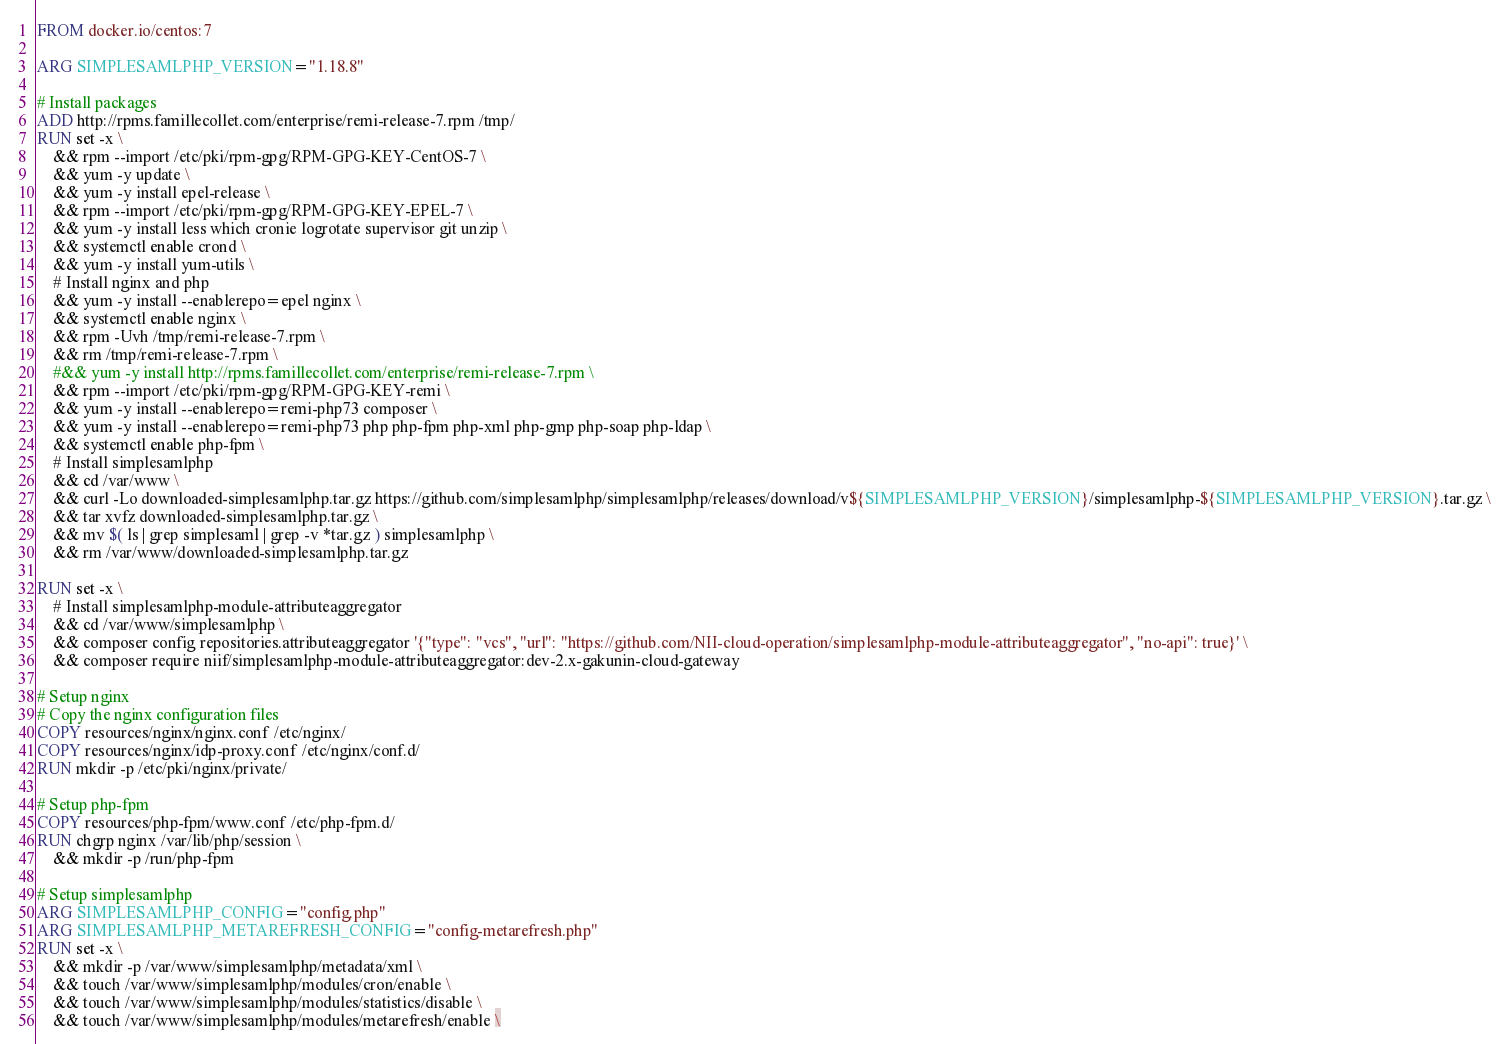Convert code to text. <code><loc_0><loc_0><loc_500><loc_500><_Dockerfile_>FROM docker.io/centos:7

ARG SIMPLESAMLPHP_VERSION="1.18.8"

# Install packages
ADD http://rpms.famillecollet.com/enterprise/remi-release-7.rpm /tmp/
RUN set -x \
    && rpm --import /etc/pki/rpm-gpg/RPM-GPG-KEY-CentOS-7 \
    && yum -y update \
    && yum -y install epel-release \
    && rpm --import /etc/pki/rpm-gpg/RPM-GPG-KEY-EPEL-7 \
    && yum -y install less which cronie logrotate supervisor git unzip \
    && systemctl enable crond \
    && yum -y install yum-utils \
    # Install nginx and php
    && yum -y install --enablerepo=epel nginx \
    && systemctl enable nginx \
    && rpm -Uvh /tmp/remi-release-7.rpm \
    && rm /tmp/remi-release-7.rpm \
    #&& yum -y install http://rpms.famillecollet.com/enterprise/remi-release-7.rpm \
    && rpm --import /etc/pki/rpm-gpg/RPM-GPG-KEY-remi \
    && yum -y install --enablerepo=remi-php73 composer \
    && yum -y install --enablerepo=remi-php73 php php-fpm php-xml php-gmp php-soap php-ldap \
    && systemctl enable php-fpm \
    # Install simplesamlphp
    && cd /var/www \
    && curl -Lo downloaded-simplesamlphp.tar.gz https://github.com/simplesamlphp/simplesamlphp/releases/download/v${SIMPLESAMLPHP_VERSION}/simplesamlphp-${SIMPLESAMLPHP_VERSION}.tar.gz \
    && tar xvfz downloaded-simplesamlphp.tar.gz \
    && mv $( ls | grep simplesaml | grep -v *tar.gz ) simplesamlphp \
    && rm /var/www/downloaded-simplesamlphp.tar.gz

RUN set -x \
    # Install simplesamlphp-module-attributeaggregator
    && cd /var/www/simplesamlphp \
    && composer config repositories.attributeaggregator '{"type": "vcs", "url": "https://github.com/NII-cloud-operation/simplesamlphp-module-attributeaggregator", "no-api": true}' \
    && composer require niif/simplesamlphp-module-attributeaggregator:dev-2.x-gakunin-cloud-gateway

# Setup nginx
# Copy the nginx configuration files
COPY resources/nginx/nginx.conf /etc/nginx/
COPY resources/nginx/idp-proxy.conf /etc/nginx/conf.d/
RUN mkdir -p /etc/pki/nginx/private/

# Setup php-fpm
COPY resources/php-fpm/www.conf /etc/php-fpm.d/
RUN chgrp nginx /var/lib/php/session \
    && mkdir -p /run/php-fpm

# Setup simplesamlphp
ARG SIMPLESAMLPHP_CONFIG="config.php"
ARG SIMPLESAMLPHP_METAREFRESH_CONFIG="config-metarefresh.php"
RUN set -x \
    && mkdir -p /var/www/simplesamlphp/metadata/xml \
    && touch /var/www/simplesamlphp/modules/cron/enable \
    && touch /var/www/simplesamlphp/modules/statistics/disable \
    && touch /var/www/simplesamlphp/modules/metarefresh/enable \</code> 